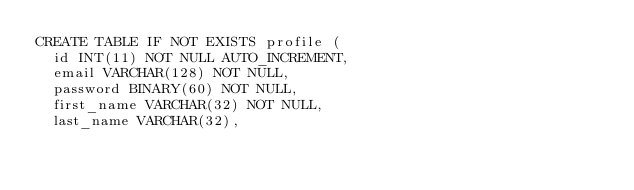Convert code to text. <code><loc_0><loc_0><loc_500><loc_500><_SQL_>CREATE TABLE IF NOT EXISTS profile (
  id INT(11) NOT NULL AUTO_INCREMENT,
  email VARCHAR(128) NOT NULL,
  password BINARY(60) NOT NULL,
  first_name VARCHAR(32) NOT NULL,
  last_name VARCHAR(32),</code> 